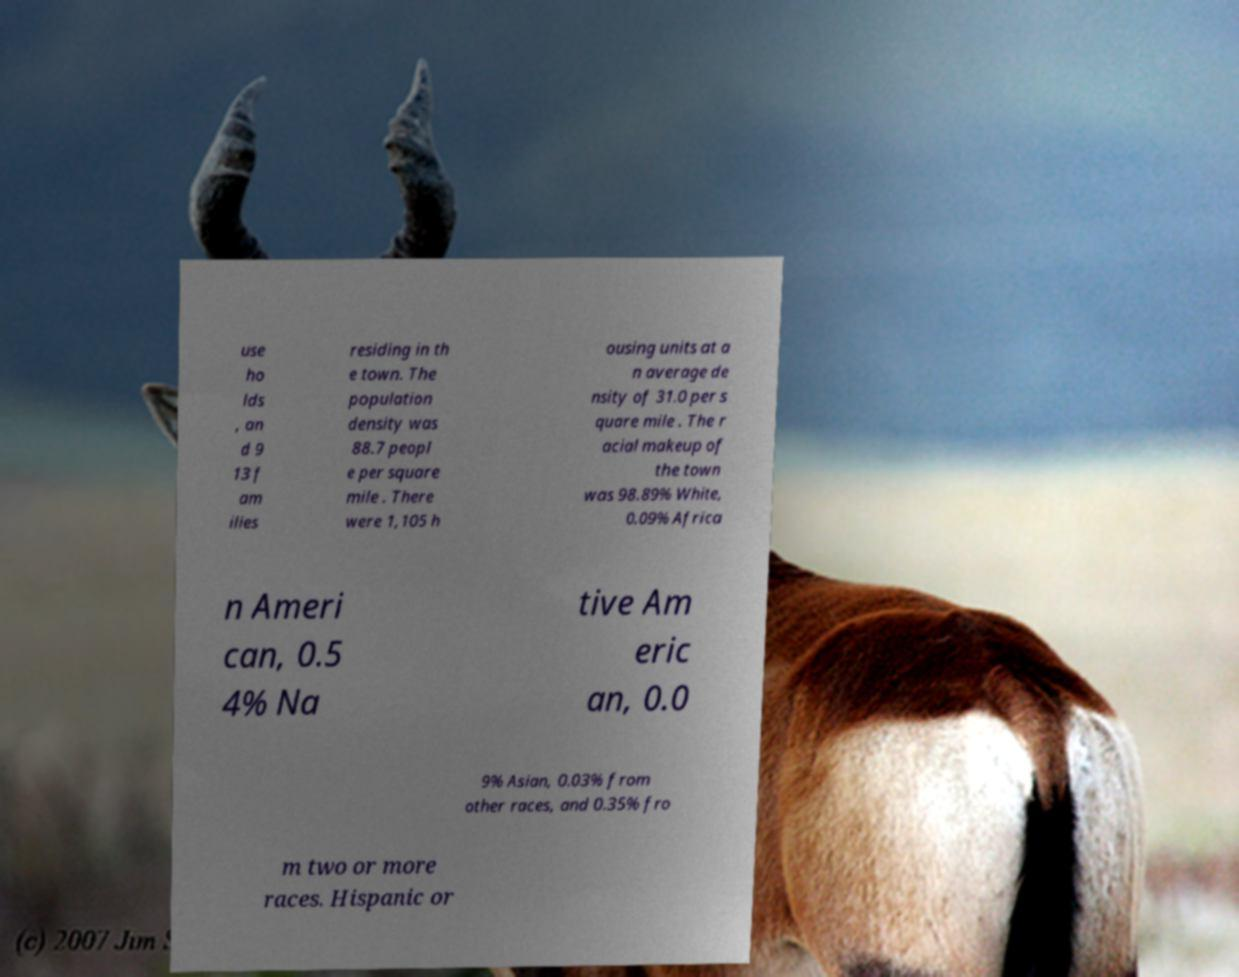Could you assist in decoding the text presented in this image and type it out clearly? use ho lds , an d 9 13 f am ilies residing in th e town. The population density was 88.7 peopl e per square mile . There were 1,105 h ousing units at a n average de nsity of 31.0 per s quare mile . The r acial makeup of the town was 98.89% White, 0.09% Africa n Ameri can, 0.5 4% Na tive Am eric an, 0.0 9% Asian, 0.03% from other races, and 0.35% fro m two or more races. Hispanic or 